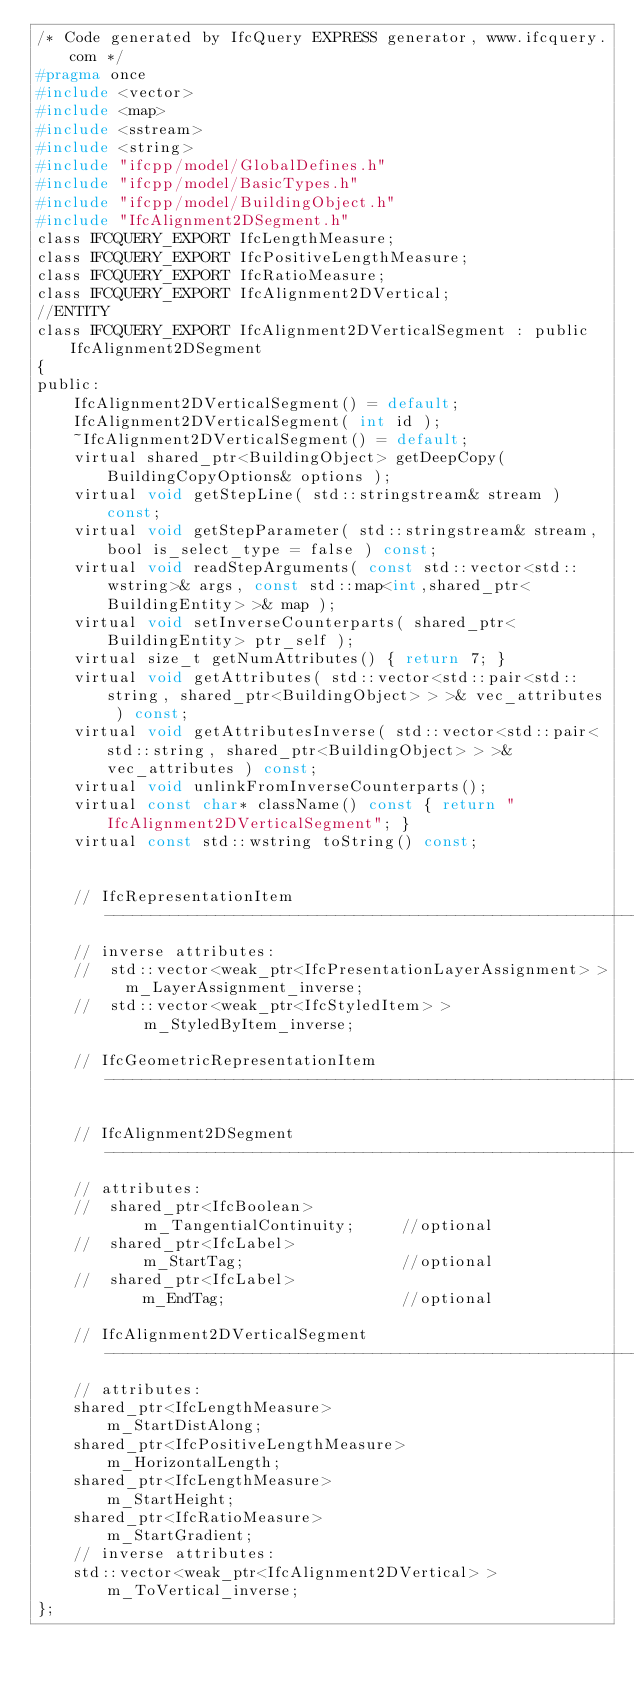<code> <loc_0><loc_0><loc_500><loc_500><_C_>/* Code generated by IfcQuery EXPRESS generator, www.ifcquery.com */
#pragma once
#include <vector>
#include <map>
#include <sstream>
#include <string>
#include "ifcpp/model/GlobalDefines.h"
#include "ifcpp/model/BasicTypes.h"
#include "ifcpp/model/BuildingObject.h"
#include "IfcAlignment2DSegment.h"
class IFCQUERY_EXPORT IfcLengthMeasure;
class IFCQUERY_EXPORT IfcPositiveLengthMeasure;
class IFCQUERY_EXPORT IfcRatioMeasure;
class IFCQUERY_EXPORT IfcAlignment2DVertical;
//ENTITY
class IFCQUERY_EXPORT IfcAlignment2DVerticalSegment : public IfcAlignment2DSegment
{ 
public:
	IfcAlignment2DVerticalSegment() = default;
	IfcAlignment2DVerticalSegment( int id );
	~IfcAlignment2DVerticalSegment() = default;
	virtual shared_ptr<BuildingObject> getDeepCopy( BuildingCopyOptions& options );
	virtual void getStepLine( std::stringstream& stream ) const;
	virtual void getStepParameter( std::stringstream& stream, bool is_select_type = false ) const;
	virtual void readStepArguments( const std::vector<std::wstring>& args, const std::map<int,shared_ptr<BuildingEntity> >& map );
	virtual void setInverseCounterparts( shared_ptr<BuildingEntity> ptr_self );
	virtual size_t getNumAttributes() { return 7; }
	virtual void getAttributes( std::vector<std::pair<std::string, shared_ptr<BuildingObject> > >& vec_attributes ) const;
	virtual void getAttributesInverse( std::vector<std::pair<std::string, shared_ptr<BuildingObject> > >& vec_attributes ) const;
	virtual void unlinkFromInverseCounterparts();
	virtual const char* className() const { return "IfcAlignment2DVerticalSegment"; }
	virtual const std::wstring toString() const;


	// IfcRepresentationItem -----------------------------------------------------------
	// inverse attributes:
	//  std::vector<weak_ptr<IfcPresentationLayerAssignment> >	m_LayerAssignment_inverse;
	//  std::vector<weak_ptr<IfcStyledItem> >					m_StyledByItem_inverse;

	// IfcGeometricRepresentationItem -----------------------------------------------------------

	// IfcAlignment2DSegment -----------------------------------------------------------
	// attributes:
	//  shared_ptr<IfcBoolean>									m_TangentialContinuity;		//optional
	//  shared_ptr<IfcLabel>									m_StartTag;					//optional
	//  shared_ptr<IfcLabel>									m_EndTag;					//optional

	// IfcAlignment2DVerticalSegment -----------------------------------------------------------
	// attributes:
	shared_ptr<IfcLengthMeasure>							m_StartDistAlong;
	shared_ptr<IfcPositiveLengthMeasure>					m_HorizontalLength;
	shared_ptr<IfcLengthMeasure>							m_StartHeight;
	shared_ptr<IfcRatioMeasure>								m_StartGradient;
	// inverse attributes:
	std::vector<weak_ptr<IfcAlignment2DVertical> >			m_ToVertical_inverse;
};

</code> 